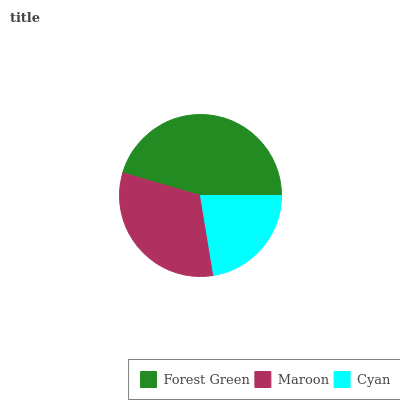Is Cyan the minimum?
Answer yes or no. Yes. Is Forest Green the maximum?
Answer yes or no. Yes. Is Maroon the minimum?
Answer yes or no. No. Is Maroon the maximum?
Answer yes or no. No. Is Forest Green greater than Maroon?
Answer yes or no. Yes. Is Maroon less than Forest Green?
Answer yes or no. Yes. Is Maroon greater than Forest Green?
Answer yes or no. No. Is Forest Green less than Maroon?
Answer yes or no. No. Is Maroon the high median?
Answer yes or no. Yes. Is Maroon the low median?
Answer yes or no. Yes. Is Forest Green the high median?
Answer yes or no. No. Is Cyan the low median?
Answer yes or no. No. 